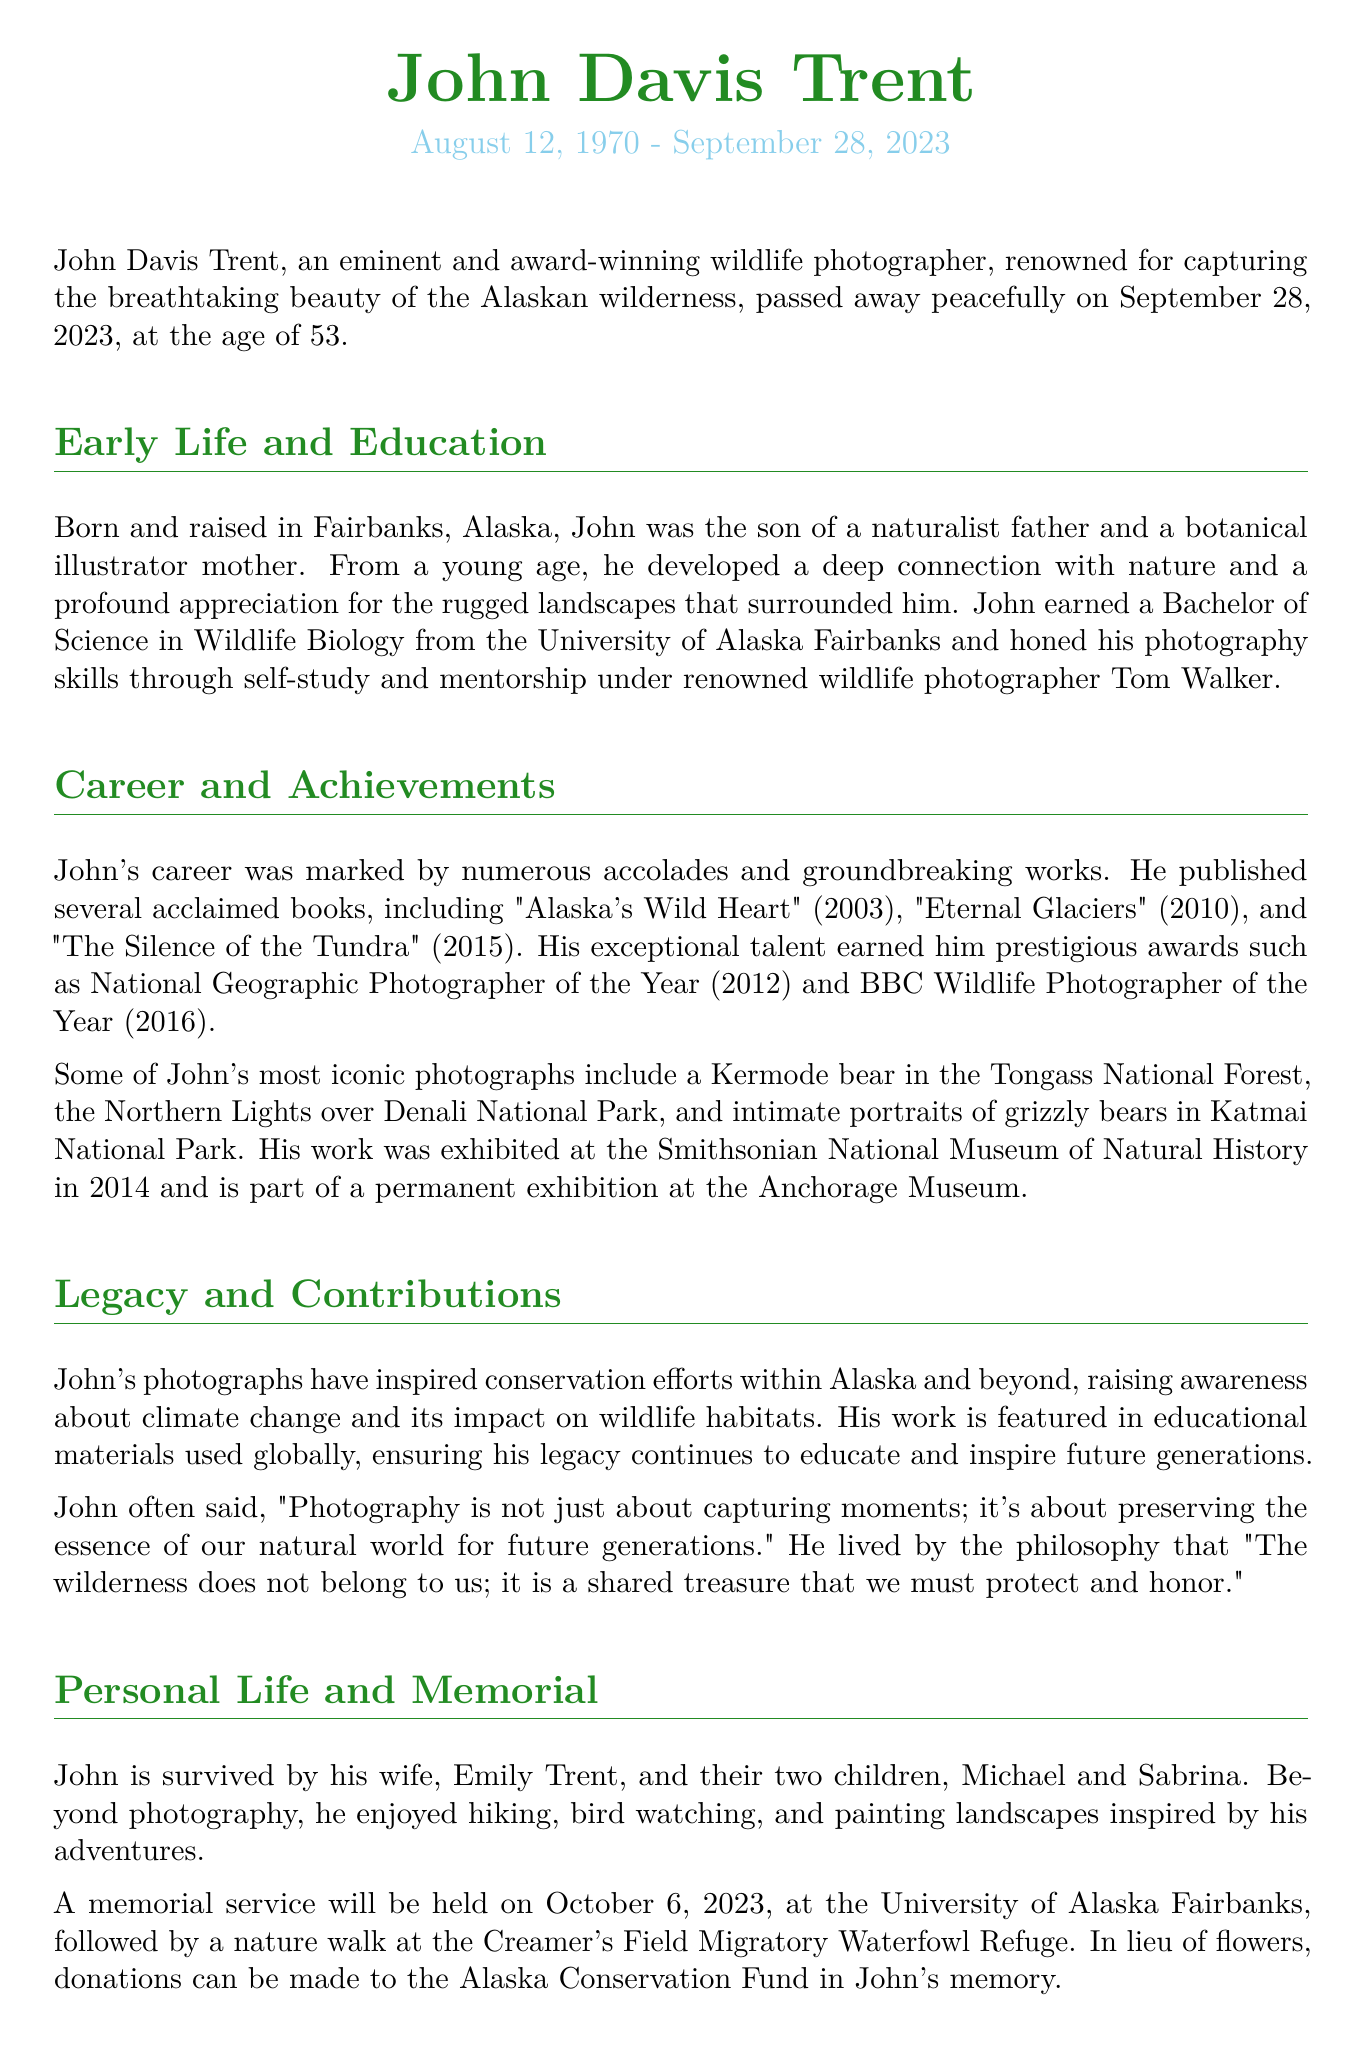What was John Davis Trent's date of birth? The document states John Davis Trent was born on August 12, 1970.
Answer: August 12, 1970 How old was John Davis Trent at the time of his death? The document mentions John passed away at the age of 53.
Answer: 53 What degrees did John Davis Trent earn? The document states he earned a Bachelor of Science in Wildlife Biology.
Answer: Bachelor of Science in Wildlife Biology Which award did he win in 2016? The document lists that he was the BBC Wildlife Photographer of the Year in 2016.
Answer: BBC Wildlife Photographer of the Year What is the title of his book published in 2010? The document includes "Eternal Glaciers" as one of John's published books in 2010.
Answer: Eternal Glaciers How did John view the wilderness? The document quotes John saying the wilderness is a shared treasure that must be protected.
Answer: A shared treasure Which museum exhibited John's work in 2014? According to the document, John's work was exhibited at the Smithsonian National Museum of Natural History.
Answer: Smithsonian National Museum of Natural History What activities did John enjoy besides photography? The document mentions hiking, bird watching, and painting landscapes as hobbies of John.
Answer: Hiking, bird watching, painting What memorial event is scheduled for October 6, 2023? The document states a memorial service followed by a nature walk is scheduled for this date.
Answer: Memorial service and nature walk 